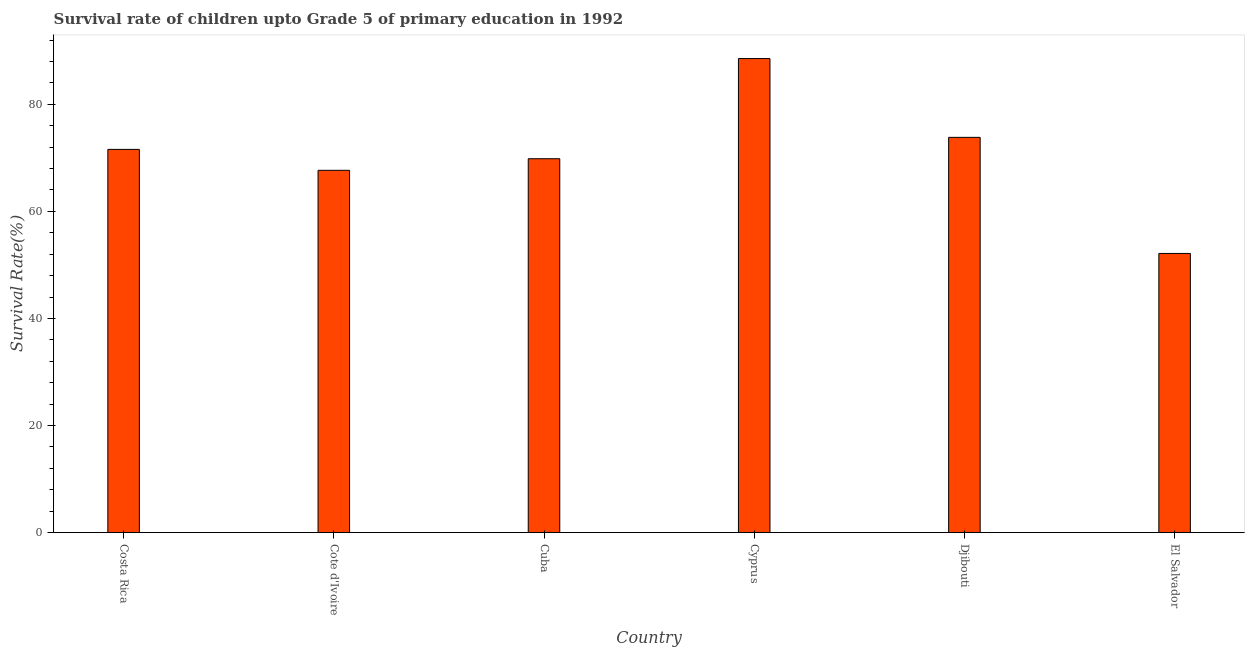Does the graph contain any zero values?
Your answer should be very brief. No. What is the title of the graph?
Your answer should be very brief. Survival rate of children upto Grade 5 of primary education in 1992 . What is the label or title of the X-axis?
Your answer should be compact. Country. What is the label or title of the Y-axis?
Your answer should be compact. Survival Rate(%). What is the survival rate in Costa Rica?
Keep it short and to the point. 71.57. Across all countries, what is the maximum survival rate?
Ensure brevity in your answer.  88.53. Across all countries, what is the minimum survival rate?
Your answer should be compact. 52.14. In which country was the survival rate maximum?
Your answer should be compact. Cyprus. In which country was the survival rate minimum?
Your answer should be very brief. El Salvador. What is the sum of the survival rate?
Keep it short and to the point. 423.55. What is the difference between the survival rate in Cuba and El Salvador?
Make the answer very short. 17.69. What is the average survival rate per country?
Your response must be concise. 70.59. What is the median survival rate?
Provide a short and direct response. 70.7. In how many countries, is the survival rate greater than 68 %?
Make the answer very short. 4. What is the ratio of the survival rate in Cote d'Ivoire to that in Djibouti?
Keep it short and to the point. 0.92. What is the difference between the highest and the second highest survival rate?
Offer a terse response. 14.72. Is the sum of the survival rate in Cuba and El Salvador greater than the maximum survival rate across all countries?
Provide a short and direct response. Yes. What is the difference between the highest and the lowest survival rate?
Your answer should be very brief. 36.4. In how many countries, is the survival rate greater than the average survival rate taken over all countries?
Give a very brief answer. 3. Are all the bars in the graph horizontal?
Offer a very short reply. No. How many countries are there in the graph?
Your answer should be very brief. 6. What is the difference between two consecutive major ticks on the Y-axis?
Provide a succinct answer. 20. Are the values on the major ticks of Y-axis written in scientific E-notation?
Your answer should be very brief. No. What is the Survival Rate(%) of Costa Rica?
Make the answer very short. 71.57. What is the Survival Rate(%) in Cote d'Ivoire?
Keep it short and to the point. 67.66. What is the Survival Rate(%) in Cuba?
Keep it short and to the point. 69.83. What is the Survival Rate(%) of Cyprus?
Provide a succinct answer. 88.53. What is the Survival Rate(%) of Djibouti?
Provide a short and direct response. 73.82. What is the Survival Rate(%) in El Salvador?
Give a very brief answer. 52.14. What is the difference between the Survival Rate(%) in Costa Rica and Cote d'Ivoire?
Provide a succinct answer. 3.91. What is the difference between the Survival Rate(%) in Costa Rica and Cuba?
Your response must be concise. 1.74. What is the difference between the Survival Rate(%) in Costa Rica and Cyprus?
Your response must be concise. -16.96. What is the difference between the Survival Rate(%) in Costa Rica and Djibouti?
Your answer should be compact. -2.25. What is the difference between the Survival Rate(%) in Costa Rica and El Salvador?
Your response must be concise. 19.43. What is the difference between the Survival Rate(%) in Cote d'Ivoire and Cuba?
Keep it short and to the point. -2.17. What is the difference between the Survival Rate(%) in Cote d'Ivoire and Cyprus?
Your answer should be very brief. -20.87. What is the difference between the Survival Rate(%) in Cote d'Ivoire and Djibouti?
Your answer should be compact. -6.15. What is the difference between the Survival Rate(%) in Cote d'Ivoire and El Salvador?
Provide a succinct answer. 15.52. What is the difference between the Survival Rate(%) in Cuba and Cyprus?
Offer a very short reply. -18.7. What is the difference between the Survival Rate(%) in Cuba and Djibouti?
Your response must be concise. -3.99. What is the difference between the Survival Rate(%) in Cuba and El Salvador?
Offer a very short reply. 17.69. What is the difference between the Survival Rate(%) in Cyprus and Djibouti?
Your answer should be compact. 14.72. What is the difference between the Survival Rate(%) in Cyprus and El Salvador?
Provide a short and direct response. 36.4. What is the difference between the Survival Rate(%) in Djibouti and El Salvador?
Provide a succinct answer. 21.68. What is the ratio of the Survival Rate(%) in Costa Rica to that in Cote d'Ivoire?
Provide a succinct answer. 1.06. What is the ratio of the Survival Rate(%) in Costa Rica to that in Cuba?
Your answer should be compact. 1.02. What is the ratio of the Survival Rate(%) in Costa Rica to that in Cyprus?
Offer a very short reply. 0.81. What is the ratio of the Survival Rate(%) in Costa Rica to that in Djibouti?
Ensure brevity in your answer.  0.97. What is the ratio of the Survival Rate(%) in Costa Rica to that in El Salvador?
Your answer should be compact. 1.37. What is the ratio of the Survival Rate(%) in Cote d'Ivoire to that in Cuba?
Keep it short and to the point. 0.97. What is the ratio of the Survival Rate(%) in Cote d'Ivoire to that in Cyprus?
Make the answer very short. 0.76. What is the ratio of the Survival Rate(%) in Cote d'Ivoire to that in Djibouti?
Make the answer very short. 0.92. What is the ratio of the Survival Rate(%) in Cote d'Ivoire to that in El Salvador?
Provide a short and direct response. 1.3. What is the ratio of the Survival Rate(%) in Cuba to that in Cyprus?
Offer a very short reply. 0.79. What is the ratio of the Survival Rate(%) in Cuba to that in Djibouti?
Offer a very short reply. 0.95. What is the ratio of the Survival Rate(%) in Cuba to that in El Salvador?
Provide a succinct answer. 1.34. What is the ratio of the Survival Rate(%) in Cyprus to that in Djibouti?
Ensure brevity in your answer.  1.2. What is the ratio of the Survival Rate(%) in Cyprus to that in El Salvador?
Give a very brief answer. 1.7. What is the ratio of the Survival Rate(%) in Djibouti to that in El Salvador?
Your answer should be very brief. 1.42. 